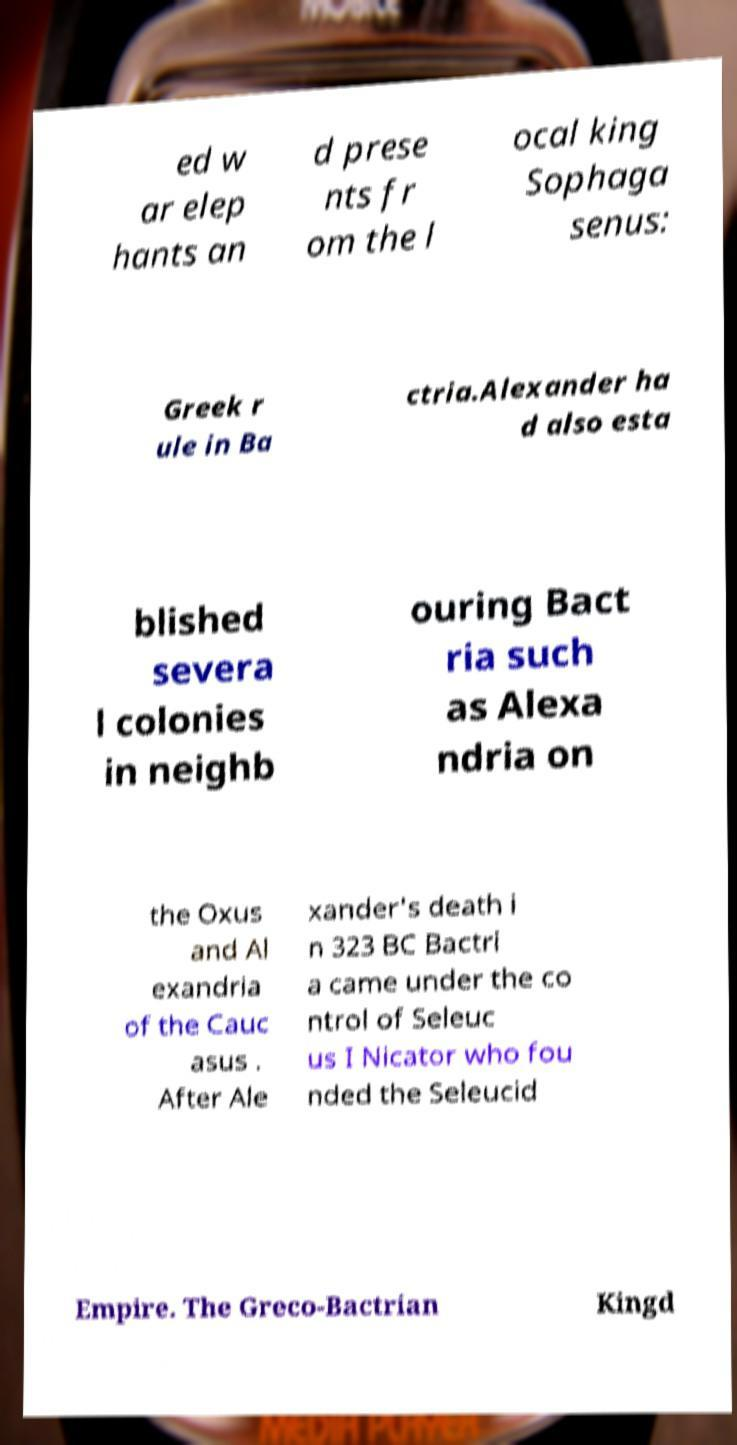I need the written content from this picture converted into text. Can you do that? ed w ar elep hants an d prese nts fr om the l ocal king Sophaga senus: Greek r ule in Ba ctria.Alexander ha d also esta blished severa l colonies in neighb ouring Bact ria such as Alexa ndria on the Oxus and Al exandria of the Cauc asus . After Ale xander's death i n 323 BC Bactri a came under the co ntrol of Seleuc us I Nicator who fou nded the Seleucid Empire. The Greco-Bactrian Kingd 